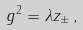<formula> <loc_0><loc_0><loc_500><loc_500>g ^ { 2 } = \lambda z _ { \pm } \, ,</formula> 